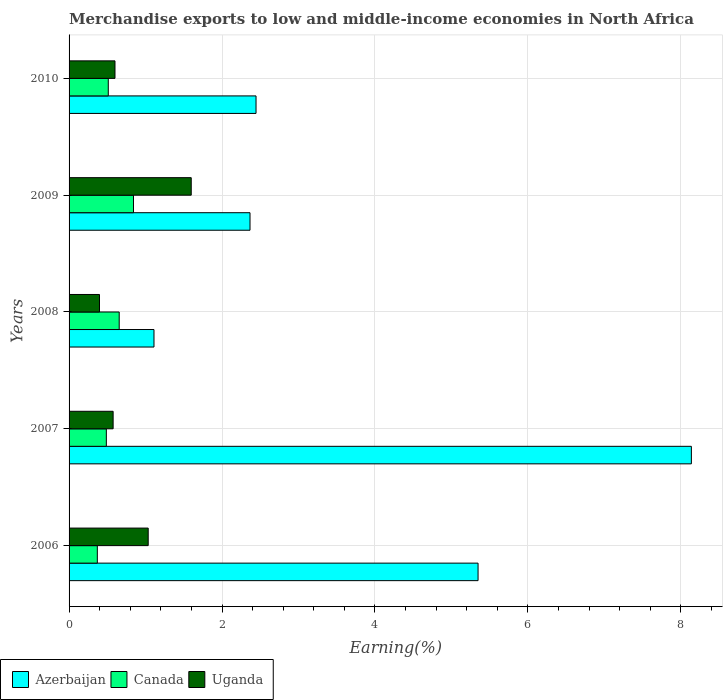How many groups of bars are there?
Keep it short and to the point. 5. What is the percentage of amount earned from merchandise exports in Azerbaijan in 2008?
Your answer should be very brief. 1.11. Across all years, what is the maximum percentage of amount earned from merchandise exports in Uganda?
Offer a terse response. 1.6. Across all years, what is the minimum percentage of amount earned from merchandise exports in Azerbaijan?
Your answer should be compact. 1.11. In which year was the percentage of amount earned from merchandise exports in Canada minimum?
Provide a short and direct response. 2006. What is the total percentage of amount earned from merchandise exports in Uganda in the graph?
Offer a very short reply. 4.21. What is the difference between the percentage of amount earned from merchandise exports in Canada in 2006 and that in 2010?
Ensure brevity in your answer.  -0.14. What is the difference between the percentage of amount earned from merchandise exports in Azerbaijan in 2006 and the percentage of amount earned from merchandise exports in Uganda in 2010?
Make the answer very short. 4.75. What is the average percentage of amount earned from merchandise exports in Canada per year?
Your answer should be very brief. 0.57. In the year 2009, what is the difference between the percentage of amount earned from merchandise exports in Uganda and percentage of amount earned from merchandise exports in Canada?
Provide a succinct answer. 0.76. What is the ratio of the percentage of amount earned from merchandise exports in Canada in 2006 to that in 2009?
Provide a succinct answer. 0.44. Is the percentage of amount earned from merchandise exports in Uganda in 2006 less than that in 2008?
Make the answer very short. No. Is the difference between the percentage of amount earned from merchandise exports in Uganda in 2006 and 2009 greater than the difference between the percentage of amount earned from merchandise exports in Canada in 2006 and 2009?
Your response must be concise. No. What is the difference between the highest and the second highest percentage of amount earned from merchandise exports in Canada?
Give a very brief answer. 0.19. What is the difference between the highest and the lowest percentage of amount earned from merchandise exports in Canada?
Offer a very short reply. 0.47. Is the sum of the percentage of amount earned from merchandise exports in Canada in 2006 and 2008 greater than the maximum percentage of amount earned from merchandise exports in Azerbaijan across all years?
Your answer should be compact. No. What does the 1st bar from the top in 2006 represents?
Provide a succinct answer. Uganda. What does the 2nd bar from the bottom in 2006 represents?
Ensure brevity in your answer.  Canada. How many years are there in the graph?
Your response must be concise. 5. Does the graph contain grids?
Provide a short and direct response. Yes. What is the title of the graph?
Make the answer very short. Merchandise exports to low and middle-income economies in North Africa. Does "St. Martin (French part)" appear as one of the legend labels in the graph?
Make the answer very short. No. What is the label or title of the X-axis?
Your response must be concise. Earning(%). What is the Earning(%) of Azerbaijan in 2006?
Provide a short and direct response. 5.35. What is the Earning(%) of Canada in 2006?
Provide a short and direct response. 0.37. What is the Earning(%) of Uganda in 2006?
Your answer should be very brief. 1.03. What is the Earning(%) in Azerbaijan in 2007?
Offer a terse response. 8.14. What is the Earning(%) in Canada in 2007?
Your answer should be compact. 0.49. What is the Earning(%) of Uganda in 2007?
Offer a terse response. 0.58. What is the Earning(%) of Azerbaijan in 2008?
Provide a succinct answer. 1.11. What is the Earning(%) of Canada in 2008?
Your answer should be very brief. 0.66. What is the Earning(%) in Uganda in 2008?
Your answer should be compact. 0.4. What is the Earning(%) in Azerbaijan in 2009?
Keep it short and to the point. 2.37. What is the Earning(%) in Canada in 2009?
Keep it short and to the point. 0.84. What is the Earning(%) in Uganda in 2009?
Ensure brevity in your answer.  1.6. What is the Earning(%) of Azerbaijan in 2010?
Offer a very short reply. 2.44. What is the Earning(%) of Canada in 2010?
Give a very brief answer. 0.51. What is the Earning(%) of Uganda in 2010?
Ensure brevity in your answer.  0.6. Across all years, what is the maximum Earning(%) in Azerbaijan?
Your answer should be very brief. 8.14. Across all years, what is the maximum Earning(%) of Canada?
Offer a very short reply. 0.84. Across all years, what is the maximum Earning(%) of Uganda?
Offer a terse response. 1.6. Across all years, what is the minimum Earning(%) in Azerbaijan?
Keep it short and to the point. 1.11. Across all years, what is the minimum Earning(%) in Canada?
Your response must be concise. 0.37. Across all years, what is the minimum Earning(%) of Uganda?
Offer a terse response. 0.4. What is the total Earning(%) in Azerbaijan in the graph?
Your answer should be compact. 19.41. What is the total Earning(%) in Canada in the graph?
Your answer should be very brief. 2.87. What is the total Earning(%) in Uganda in the graph?
Make the answer very short. 4.21. What is the difference between the Earning(%) in Azerbaijan in 2006 and that in 2007?
Keep it short and to the point. -2.79. What is the difference between the Earning(%) in Canada in 2006 and that in 2007?
Offer a very short reply. -0.12. What is the difference between the Earning(%) of Uganda in 2006 and that in 2007?
Provide a succinct answer. 0.46. What is the difference between the Earning(%) in Azerbaijan in 2006 and that in 2008?
Provide a succinct answer. 4.24. What is the difference between the Earning(%) of Canada in 2006 and that in 2008?
Your response must be concise. -0.29. What is the difference between the Earning(%) in Uganda in 2006 and that in 2008?
Your response must be concise. 0.64. What is the difference between the Earning(%) in Azerbaijan in 2006 and that in 2009?
Provide a short and direct response. 2.98. What is the difference between the Earning(%) of Canada in 2006 and that in 2009?
Your answer should be very brief. -0.47. What is the difference between the Earning(%) of Uganda in 2006 and that in 2009?
Keep it short and to the point. -0.56. What is the difference between the Earning(%) in Azerbaijan in 2006 and that in 2010?
Offer a terse response. 2.9. What is the difference between the Earning(%) in Canada in 2006 and that in 2010?
Make the answer very short. -0.14. What is the difference between the Earning(%) of Uganda in 2006 and that in 2010?
Keep it short and to the point. 0.43. What is the difference between the Earning(%) in Azerbaijan in 2007 and that in 2008?
Give a very brief answer. 7.03. What is the difference between the Earning(%) in Canada in 2007 and that in 2008?
Your answer should be very brief. -0.17. What is the difference between the Earning(%) of Uganda in 2007 and that in 2008?
Offer a terse response. 0.18. What is the difference between the Earning(%) in Azerbaijan in 2007 and that in 2009?
Offer a terse response. 5.77. What is the difference between the Earning(%) in Canada in 2007 and that in 2009?
Your answer should be compact. -0.35. What is the difference between the Earning(%) in Uganda in 2007 and that in 2009?
Your answer should be very brief. -1.02. What is the difference between the Earning(%) in Azerbaijan in 2007 and that in 2010?
Your answer should be very brief. 5.69. What is the difference between the Earning(%) in Canada in 2007 and that in 2010?
Provide a succinct answer. -0.03. What is the difference between the Earning(%) of Uganda in 2007 and that in 2010?
Your response must be concise. -0.02. What is the difference between the Earning(%) in Azerbaijan in 2008 and that in 2009?
Give a very brief answer. -1.26. What is the difference between the Earning(%) of Canada in 2008 and that in 2009?
Keep it short and to the point. -0.19. What is the difference between the Earning(%) of Uganda in 2008 and that in 2009?
Offer a very short reply. -1.2. What is the difference between the Earning(%) in Azerbaijan in 2008 and that in 2010?
Provide a short and direct response. -1.33. What is the difference between the Earning(%) in Canada in 2008 and that in 2010?
Give a very brief answer. 0.14. What is the difference between the Earning(%) in Uganda in 2008 and that in 2010?
Your answer should be very brief. -0.2. What is the difference between the Earning(%) in Azerbaijan in 2009 and that in 2010?
Your response must be concise. -0.08. What is the difference between the Earning(%) of Canada in 2009 and that in 2010?
Give a very brief answer. 0.33. What is the difference between the Earning(%) of Azerbaijan in 2006 and the Earning(%) of Canada in 2007?
Your answer should be compact. 4.86. What is the difference between the Earning(%) of Azerbaijan in 2006 and the Earning(%) of Uganda in 2007?
Your answer should be compact. 4.77. What is the difference between the Earning(%) of Canada in 2006 and the Earning(%) of Uganda in 2007?
Offer a very short reply. -0.21. What is the difference between the Earning(%) of Azerbaijan in 2006 and the Earning(%) of Canada in 2008?
Give a very brief answer. 4.69. What is the difference between the Earning(%) of Azerbaijan in 2006 and the Earning(%) of Uganda in 2008?
Ensure brevity in your answer.  4.95. What is the difference between the Earning(%) in Canada in 2006 and the Earning(%) in Uganda in 2008?
Provide a short and direct response. -0.03. What is the difference between the Earning(%) in Azerbaijan in 2006 and the Earning(%) in Canada in 2009?
Give a very brief answer. 4.51. What is the difference between the Earning(%) in Azerbaijan in 2006 and the Earning(%) in Uganda in 2009?
Offer a terse response. 3.75. What is the difference between the Earning(%) in Canada in 2006 and the Earning(%) in Uganda in 2009?
Provide a short and direct response. -1.23. What is the difference between the Earning(%) in Azerbaijan in 2006 and the Earning(%) in Canada in 2010?
Ensure brevity in your answer.  4.84. What is the difference between the Earning(%) of Azerbaijan in 2006 and the Earning(%) of Uganda in 2010?
Ensure brevity in your answer.  4.75. What is the difference between the Earning(%) of Canada in 2006 and the Earning(%) of Uganda in 2010?
Your response must be concise. -0.23. What is the difference between the Earning(%) in Azerbaijan in 2007 and the Earning(%) in Canada in 2008?
Your answer should be compact. 7.48. What is the difference between the Earning(%) of Azerbaijan in 2007 and the Earning(%) of Uganda in 2008?
Offer a terse response. 7.74. What is the difference between the Earning(%) of Canada in 2007 and the Earning(%) of Uganda in 2008?
Give a very brief answer. 0.09. What is the difference between the Earning(%) of Azerbaijan in 2007 and the Earning(%) of Canada in 2009?
Ensure brevity in your answer.  7.3. What is the difference between the Earning(%) of Azerbaijan in 2007 and the Earning(%) of Uganda in 2009?
Offer a very short reply. 6.54. What is the difference between the Earning(%) in Canada in 2007 and the Earning(%) in Uganda in 2009?
Give a very brief answer. -1.11. What is the difference between the Earning(%) of Azerbaijan in 2007 and the Earning(%) of Canada in 2010?
Provide a succinct answer. 7.62. What is the difference between the Earning(%) in Azerbaijan in 2007 and the Earning(%) in Uganda in 2010?
Your answer should be very brief. 7.54. What is the difference between the Earning(%) in Canada in 2007 and the Earning(%) in Uganda in 2010?
Offer a terse response. -0.11. What is the difference between the Earning(%) in Azerbaijan in 2008 and the Earning(%) in Canada in 2009?
Offer a terse response. 0.27. What is the difference between the Earning(%) of Azerbaijan in 2008 and the Earning(%) of Uganda in 2009?
Your answer should be very brief. -0.49. What is the difference between the Earning(%) in Canada in 2008 and the Earning(%) in Uganda in 2009?
Provide a succinct answer. -0.94. What is the difference between the Earning(%) of Azerbaijan in 2008 and the Earning(%) of Canada in 2010?
Give a very brief answer. 0.6. What is the difference between the Earning(%) of Azerbaijan in 2008 and the Earning(%) of Uganda in 2010?
Offer a very short reply. 0.51. What is the difference between the Earning(%) of Canada in 2008 and the Earning(%) of Uganda in 2010?
Offer a terse response. 0.06. What is the difference between the Earning(%) in Azerbaijan in 2009 and the Earning(%) in Canada in 2010?
Make the answer very short. 1.85. What is the difference between the Earning(%) of Azerbaijan in 2009 and the Earning(%) of Uganda in 2010?
Give a very brief answer. 1.77. What is the difference between the Earning(%) in Canada in 2009 and the Earning(%) in Uganda in 2010?
Keep it short and to the point. 0.24. What is the average Earning(%) in Azerbaijan per year?
Your answer should be very brief. 3.88. What is the average Earning(%) in Canada per year?
Offer a terse response. 0.57. What is the average Earning(%) of Uganda per year?
Your answer should be very brief. 0.84. In the year 2006, what is the difference between the Earning(%) of Azerbaijan and Earning(%) of Canada?
Your response must be concise. 4.98. In the year 2006, what is the difference between the Earning(%) of Azerbaijan and Earning(%) of Uganda?
Offer a terse response. 4.31. In the year 2006, what is the difference between the Earning(%) of Canada and Earning(%) of Uganda?
Your response must be concise. -0.67. In the year 2007, what is the difference between the Earning(%) in Azerbaijan and Earning(%) in Canada?
Make the answer very short. 7.65. In the year 2007, what is the difference between the Earning(%) in Azerbaijan and Earning(%) in Uganda?
Your answer should be compact. 7.56. In the year 2007, what is the difference between the Earning(%) in Canada and Earning(%) in Uganda?
Your answer should be very brief. -0.09. In the year 2008, what is the difference between the Earning(%) in Azerbaijan and Earning(%) in Canada?
Provide a succinct answer. 0.45. In the year 2008, what is the difference between the Earning(%) of Azerbaijan and Earning(%) of Uganda?
Make the answer very short. 0.71. In the year 2008, what is the difference between the Earning(%) in Canada and Earning(%) in Uganda?
Your answer should be compact. 0.26. In the year 2009, what is the difference between the Earning(%) of Azerbaijan and Earning(%) of Canada?
Ensure brevity in your answer.  1.52. In the year 2009, what is the difference between the Earning(%) of Azerbaijan and Earning(%) of Uganda?
Your answer should be compact. 0.77. In the year 2009, what is the difference between the Earning(%) of Canada and Earning(%) of Uganda?
Your response must be concise. -0.76. In the year 2010, what is the difference between the Earning(%) of Azerbaijan and Earning(%) of Canada?
Keep it short and to the point. 1.93. In the year 2010, what is the difference between the Earning(%) of Azerbaijan and Earning(%) of Uganda?
Your response must be concise. 1.84. In the year 2010, what is the difference between the Earning(%) of Canada and Earning(%) of Uganda?
Ensure brevity in your answer.  -0.09. What is the ratio of the Earning(%) in Azerbaijan in 2006 to that in 2007?
Ensure brevity in your answer.  0.66. What is the ratio of the Earning(%) of Canada in 2006 to that in 2007?
Make the answer very short. 0.76. What is the ratio of the Earning(%) in Uganda in 2006 to that in 2007?
Your answer should be compact. 1.8. What is the ratio of the Earning(%) of Azerbaijan in 2006 to that in 2008?
Provide a succinct answer. 4.82. What is the ratio of the Earning(%) in Canada in 2006 to that in 2008?
Ensure brevity in your answer.  0.56. What is the ratio of the Earning(%) in Uganda in 2006 to that in 2008?
Your answer should be very brief. 2.6. What is the ratio of the Earning(%) in Azerbaijan in 2006 to that in 2009?
Ensure brevity in your answer.  2.26. What is the ratio of the Earning(%) of Canada in 2006 to that in 2009?
Your answer should be compact. 0.44. What is the ratio of the Earning(%) of Uganda in 2006 to that in 2009?
Ensure brevity in your answer.  0.65. What is the ratio of the Earning(%) of Azerbaijan in 2006 to that in 2010?
Provide a succinct answer. 2.19. What is the ratio of the Earning(%) of Canada in 2006 to that in 2010?
Make the answer very short. 0.72. What is the ratio of the Earning(%) in Uganda in 2006 to that in 2010?
Offer a terse response. 1.72. What is the ratio of the Earning(%) in Azerbaijan in 2007 to that in 2008?
Make the answer very short. 7.33. What is the ratio of the Earning(%) in Canada in 2007 to that in 2008?
Offer a terse response. 0.74. What is the ratio of the Earning(%) in Uganda in 2007 to that in 2008?
Give a very brief answer. 1.45. What is the ratio of the Earning(%) of Azerbaijan in 2007 to that in 2009?
Provide a short and direct response. 3.44. What is the ratio of the Earning(%) of Canada in 2007 to that in 2009?
Keep it short and to the point. 0.58. What is the ratio of the Earning(%) in Uganda in 2007 to that in 2009?
Ensure brevity in your answer.  0.36. What is the ratio of the Earning(%) in Azerbaijan in 2007 to that in 2010?
Provide a short and direct response. 3.33. What is the ratio of the Earning(%) of Canada in 2007 to that in 2010?
Your answer should be very brief. 0.95. What is the ratio of the Earning(%) in Uganda in 2007 to that in 2010?
Offer a very short reply. 0.96. What is the ratio of the Earning(%) in Azerbaijan in 2008 to that in 2009?
Give a very brief answer. 0.47. What is the ratio of the Earning(%) of Canada in 2008 to that in 2009?
Provide a succinct answer. 0.78. What is the ratio of the Earning(%) in Uganda in 2008 to that in 2009?
Your answer should be very brief. 0.25. What is the ratio of the Earning(%) in Azerbaijan in 2008 to that in 2010?
Provide a succinct answer. 0.45. What is the ratio of the Earning(%) of Canada in 2008 to that in 2010?
Provide a short and direct response. 1.28. What is the ratio of the Earning(%) in Uganda in 2008 to that in 2010?
Ensure brevity in your answer.  0.66. What is the ratio of the Earning(%) in Azerbaijan in 2009 to that in 2010?
Your answer should be compact. 0.97. What is the ratio of the Earning(%) of Canada in 2009 to that in 2010?
Provide a short and direct response. 1.64. What is the ratio of the Earning(%) in Uganda in 2009 to that in 2010?
Your answer should be very brief. 2.66. What is the difference between the highest and the second highest Earning(%) of Azerbaijan?
Ensure brevity in your answer.  2.79. What is the difference between the highest and the second highest Earning(%) of Canada?
Keep it short and to the point. 0.19. What is the difference between the highest and the second highest Earning(%) in Uganda?
Your answer should be very brief. 0.56. What is the difference between the highest and the lowest Earning(%) of Azerbaijan?
Your answer should be very brief. 7.03. What is the difference between the highest and the lowest Earning(%) of Canada?
Your answer should be very brief. 0.47. What is the difference between the highest and the lowest Earning(%) in Uganda?
Keep it short and to the point. 1.2. 